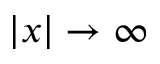<formula> <loc_0><loc_0><loc_500><loc_500>| x | \to \infty</formula> 